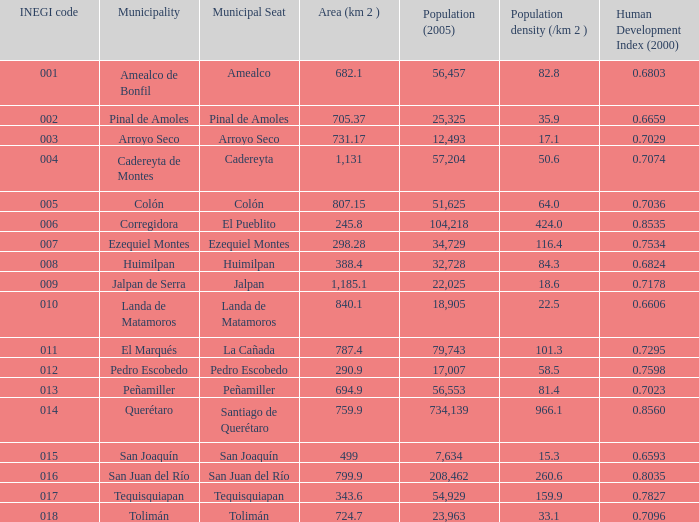Where can an area in square kilometers be found with a population of 57,204 in 2005 and a human development index below 0.7074 in 2000? 0.0. 